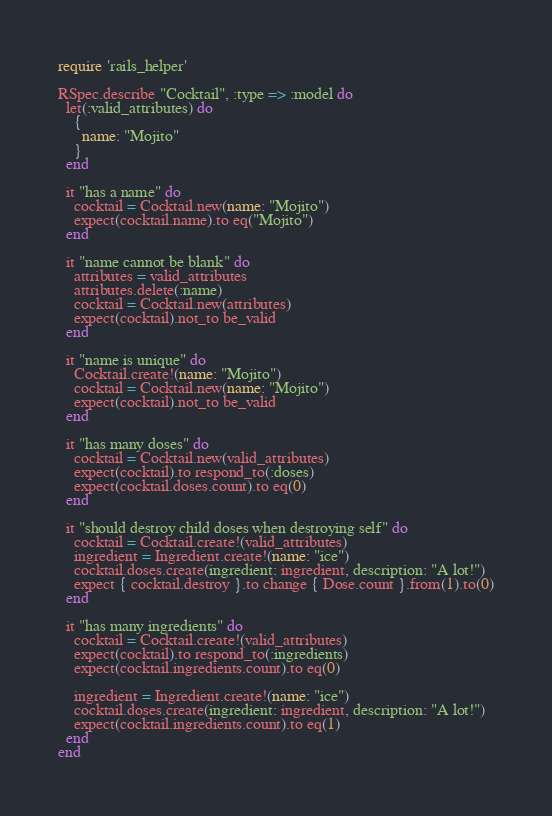Convert code to text. <code><loc_0><loc_0><loc_500><loc_500><_Ruby_>require 'rails_helper'

RSpec.describe "Cocktail", :type => :model do
  let(:valid_attributes) do
    {
      name: "Mojito"
    }
  end

  it "has a name" do
    cocktail = Cocktail.new(name: "Mojito")
    expect(cocktail.name).to eq("Mojito")
  end

  it "name cannot be blank" do
    attributes = valid_attributes
    attributes.delete(:name)
    cocktail = Cocktail.new(attributes)
    expect(cocktail).not_to be_valid
  end

  it "name is unique" do
    Cocktail.create!(name: "Mojito")
    cocktail = Cocktail.new(name: "Mojito")
    expect(cocktail).not_to be_valid
  end

  it "has many doses" do
    cocktail = Cocktail.new(valid_attributes)
    expect(cocktail).to respond_to(:doses)
    expect(cocktail.doses.count).to eq(0)
  end

  it "should destroy child doses when destroying self" do
    cocktail = Cocktail.create!(valid_attributes)
    ingredient = Ingredient.create!(name: "ice")
    cocktail.doses.create(ingredient: ingredient, description: "A lot!")
    expect { cocktail.destroy }.to change { Dose.count }.from(1).to(0)
  end

  it "has many ingredients" do
    cocktail = Cocktail.create!(valid_attributes)
    expect(cocktail).to respond_to(:ingredients)
    expect(cocktail.ingredients.count).to eq(0)

    ingredient = Ingredient.create!(name: "ice")
    cocktail.doses.create(ingredient: ingredient, description: "A lot!")
    expect(cocktail.ingredients.count).to eq(1)
  end
end
</code> 